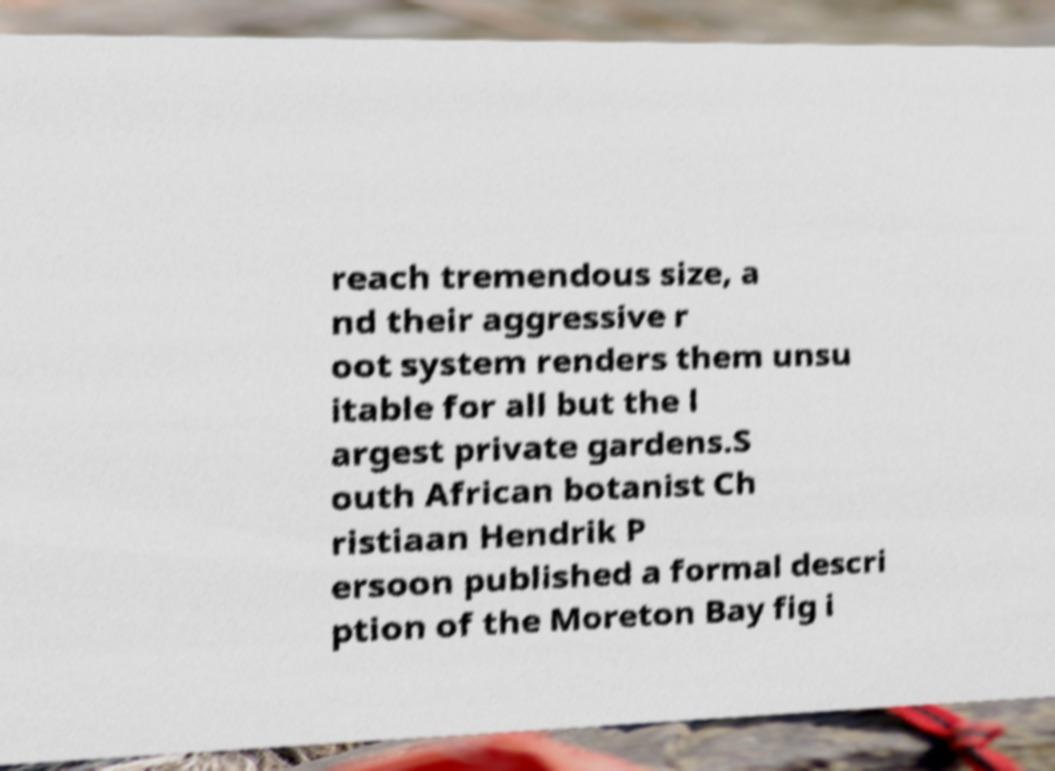Could you assist in decoding the text presented in this image and type it out clearly? reach tremendous size, a nd their aggressive r oot system renders them unsu itable for all but the l argest private gardens.S outh African botanist Ch ristiaan Hendrik P ersoon published a formal descri ption of the Moreton Bay fig i 